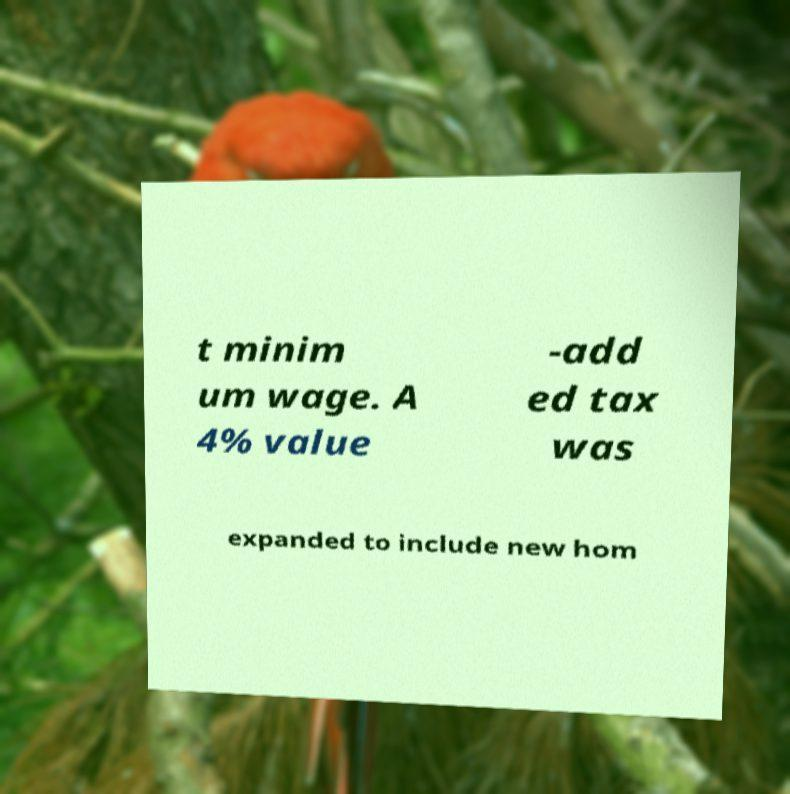Could you assist in decoding the text presented in this image and type it out clearly? t minim um wage. A 4% value -add ed tax was expanded to include new hom 